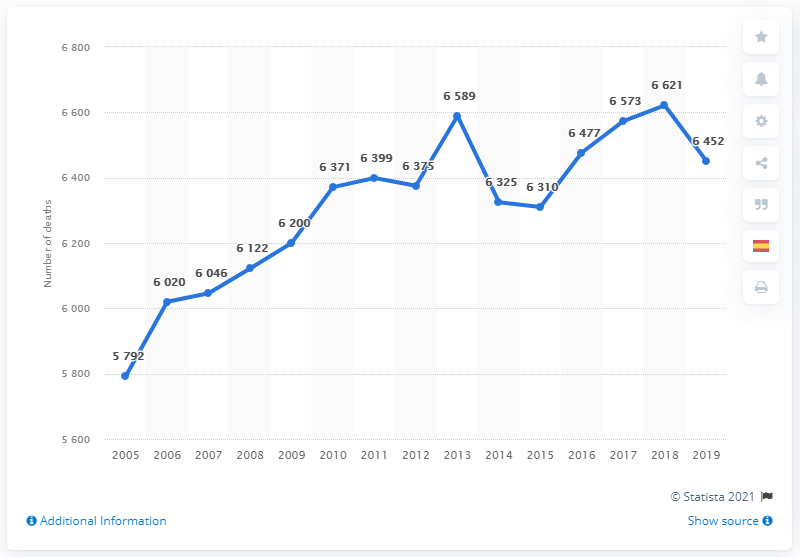Point out several critical features in this image. In 2019, an estimated 6452 deaths were caused by breast cancer in Spain. In 2005, a total of 5,792 deaths were caused by breast cancer in Spain. 